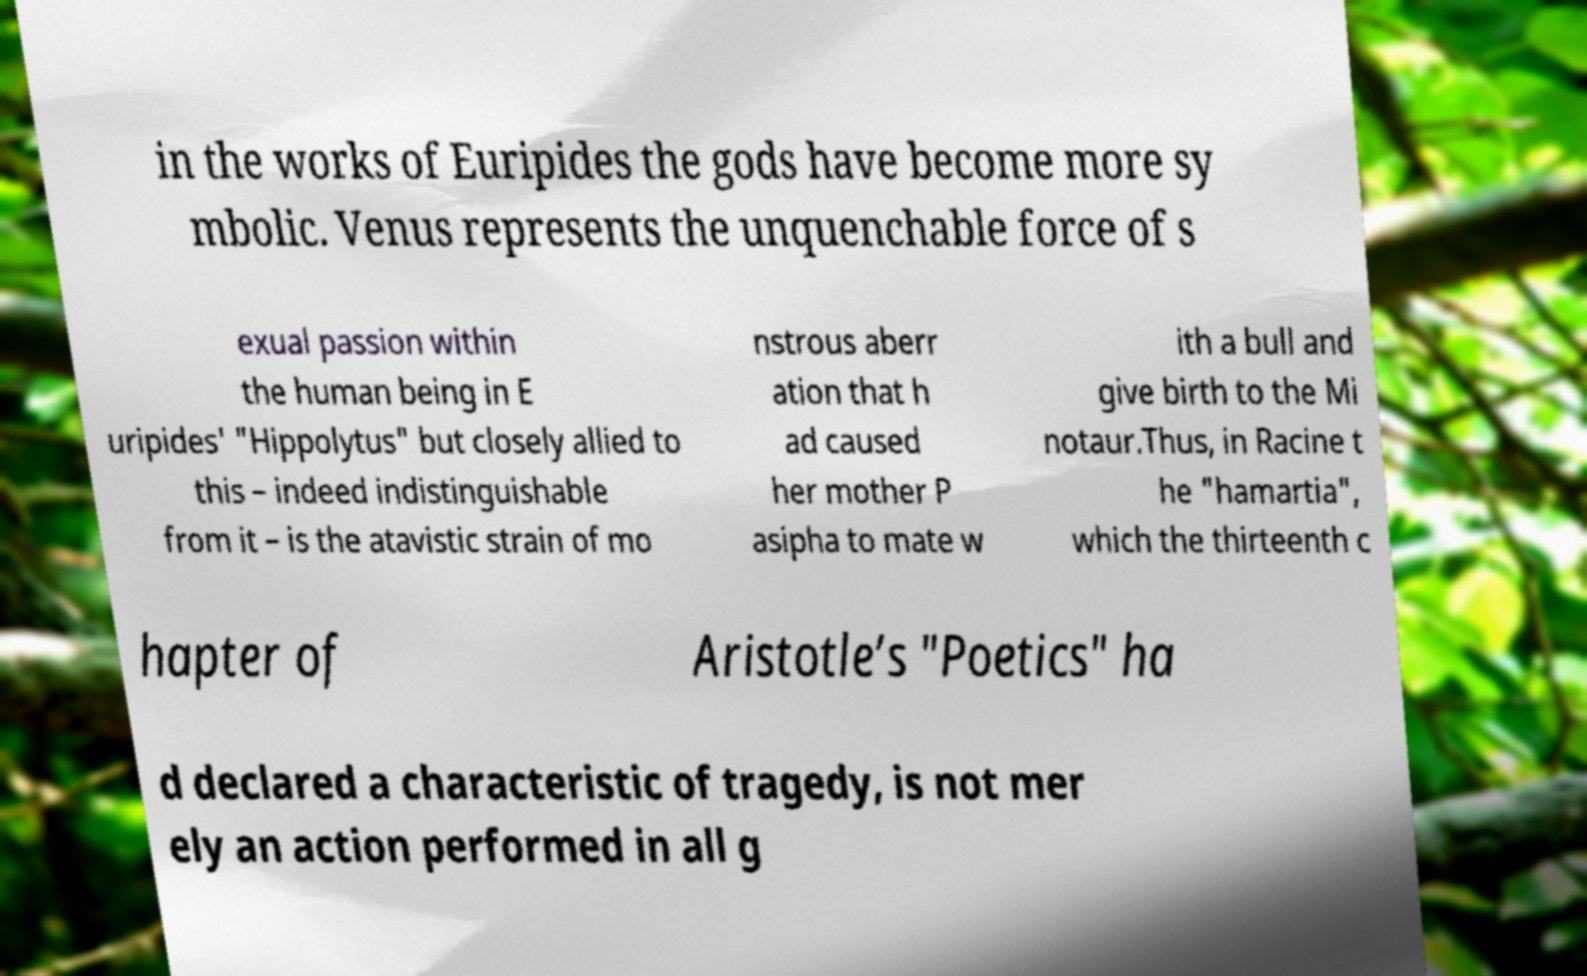There's text embedded in this image that I need extracted. Can you transcribe it verbatim? in the works of Euripides the gods have become more sy mbolic. Venus represents the unquenchable force of s exual passion within the human being in E uripides' "Hippolytus" but closely allied to this – indeed indistinguishable from it – is the atavistic strain of mo nstrous aberr ation that h ad caused her mother P asipha to mate w ith a bull and give birth to the Mi notaur.Thus, in Racine t he "hamartia", which the thirteenth c hapter of Aristotle’s "Poetics" ha d declared a characteristic of tragedy, is not mer ely an action performed in all g 